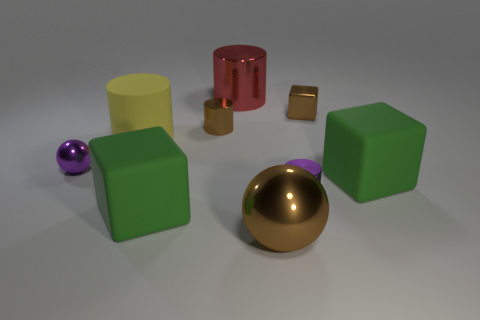Subtract all small brown cylinders. How many cylinders are left? 3 Add 1 large brown cylinders. How many objects exist? 10 Subtract all brown spheres. How many green cubes are left? 2 Subtract all brown spheres. How many spheres are left? 1 Subtract all cubes. How many objects are left? 6 Subtract 2 spheres. How many spheres are left? 0 Subtract all cyan spheres. Subtract all yellow cubes. How many spheres are left? 2 Subtract all brown cubes. Subtract all yellow cubes. How many objects are left? 8 Add 5 tiny purple metallic cylinders. How many tiny purple metallic cylinders are left? 6 Add 1 big yellow rubber cylinders. How many big yellow rubber cylinders exist? 2 